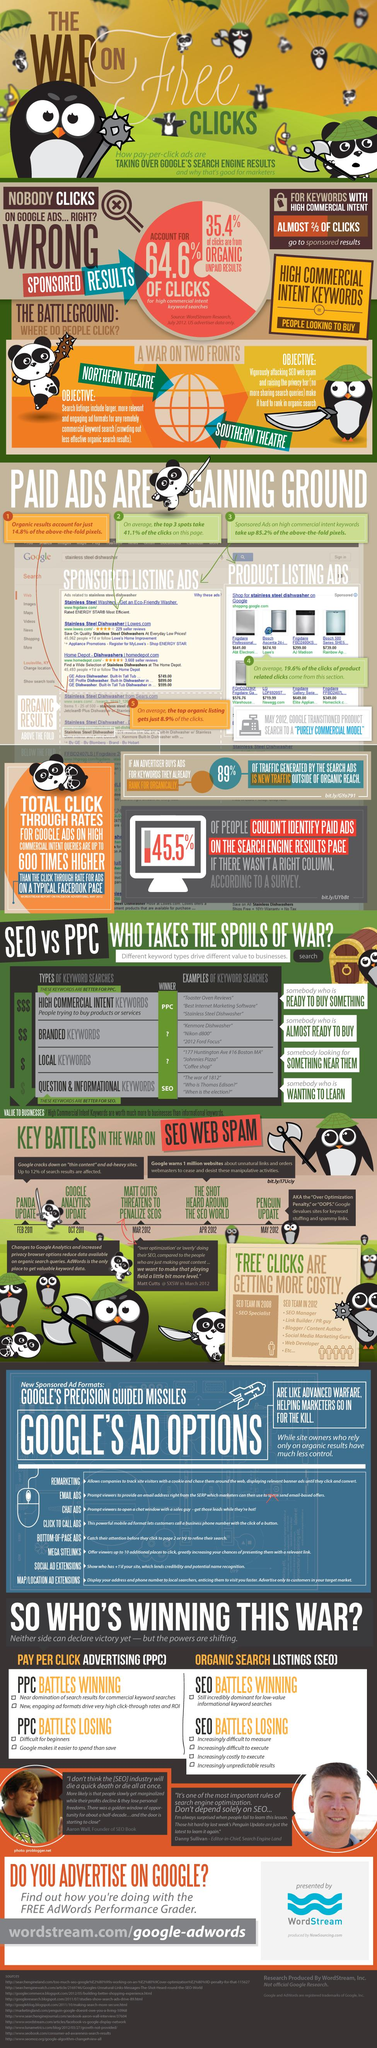Give some essential details in this illustration. Sixty-four point six percent of the clicks are for high commercial intent keywords searches. The majority of clicks for keywords with commercial intent are directed towards sponsored results. 35.4% of the clicks are coming from organic, unpaid search results. 